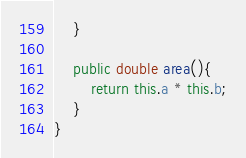<code> <loc_0><loc_0><loc_500><loc_500><_Java_>    }

    public double area(){
        return this.a * this.b;
    }
}
</code> 